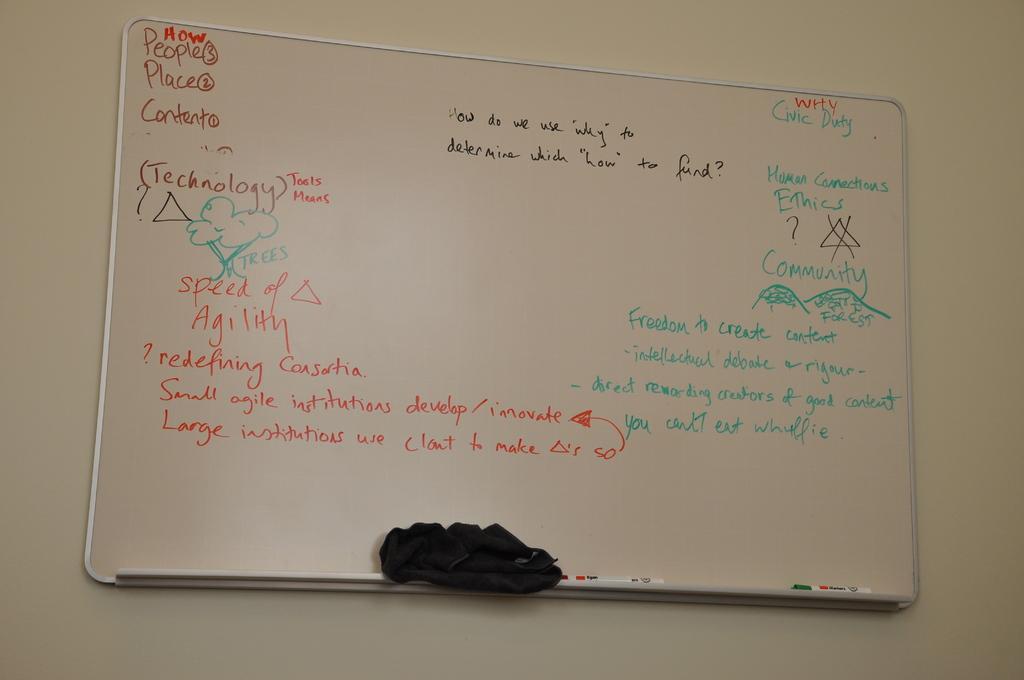Could you give a brief overview of what you see in this image? In this picture there is a board on the wall with some text written on it and on the board there is a cloth which is black in colour and there are pens. 